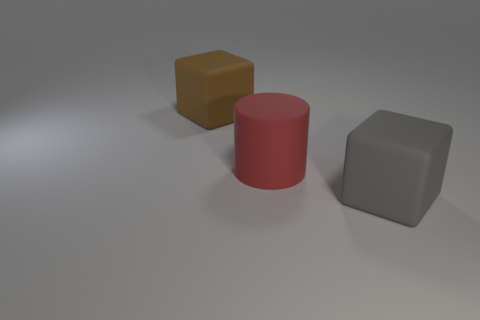Add 2 large cylinders. How many objects exist? 5 Subtract all cylinders. How many objects are left? 2 Subtract all tiny purple objects. Subtract all big gray blocks. How many objects are left? 2 Add 2 gray rubber cubes. How many gray rubber cubes are left? 3 Add 1 large things. How many large things exist? 4 Subtract 0 purple cubes. How many objects are left? 3 